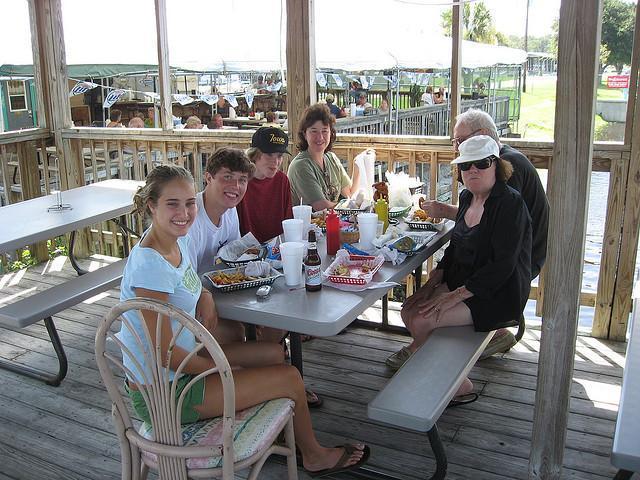How many people are eating?
Give a very brief answer. 6. How many people are in the picture?
Give a very brief answer. 6. How many dining tables can be seen?
Give a very brief answer. 2. How many benches are there?
Give a very brief answer. 2. 